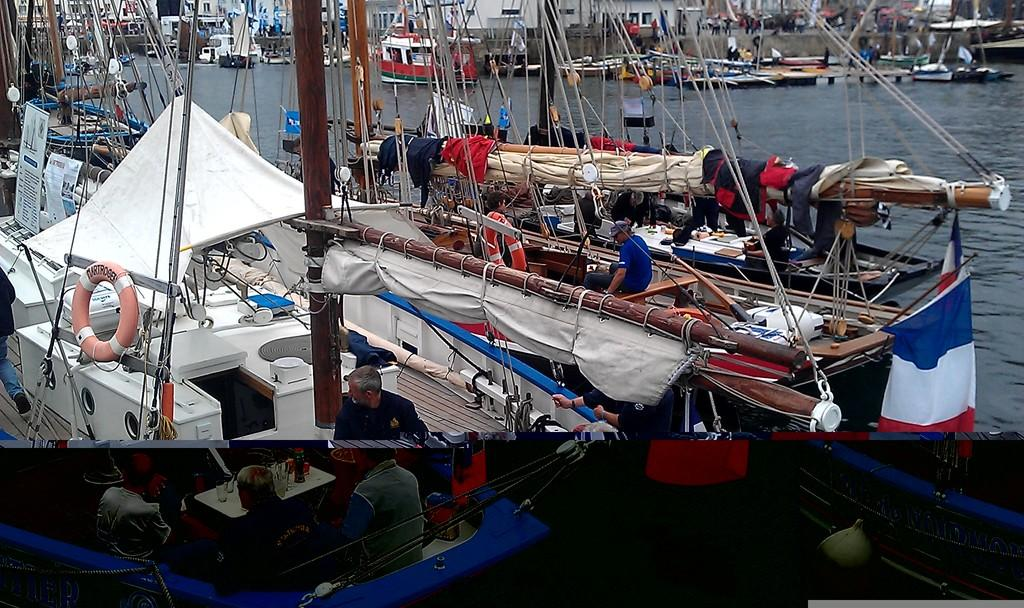What is the main subject of the image? The main subject of the image is ships. Where are the ships located? The ships are on the water. Are there any people present in the image? Yes, there are people in the ships. What type of watch can be seen on the spiders in the image? There are no spiders or watches present in the image; it features ships on the water with people in them. 